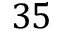<formula> <loc_0><loc_0><loc_500><loc_500>3 5</formula> 